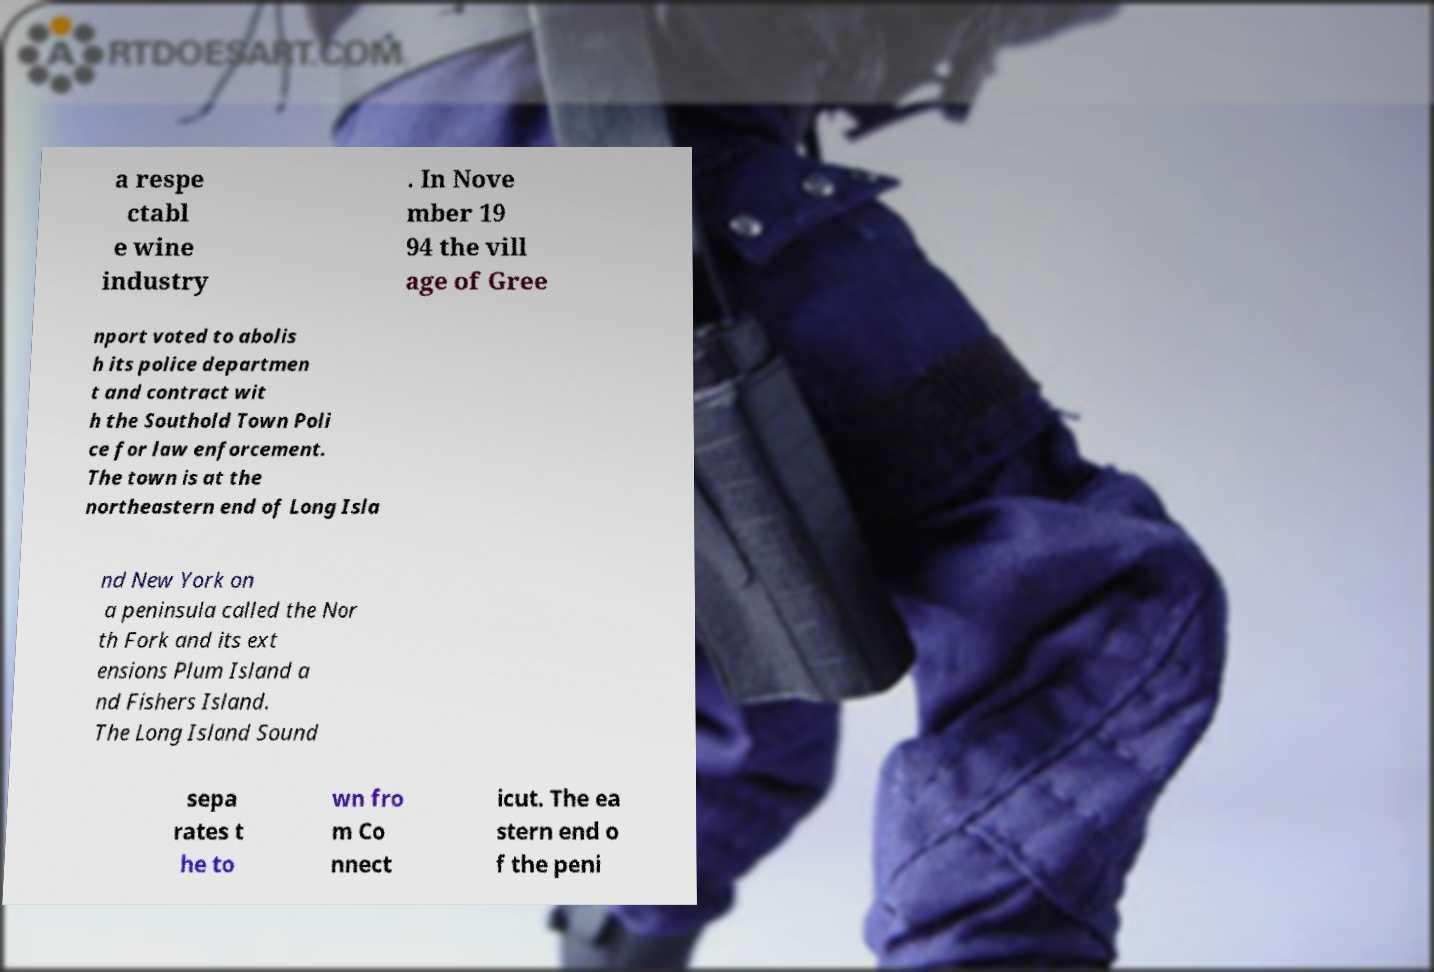Can you read and provide the text displayed in the image?This photo seems to have some interesting text. Can you extract and type it out for me? a respe ctabl e wine industry . In Nove mber 19 94 the vill age of Gree nport voted to abolis h its police departmen t and contract wit h the Southold Town Poli ce for law enforcement. The town is at the northeastern end of Long Isla nd New York on a peninsula called the Nor th Fork and its ext ensions Plum Island a nd Fishers Island. The Long Island Sound sepa rates t he to wn fro m Co nnect icut. The ea stern end o f the peni 